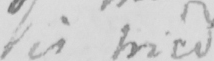What is written in this line of handwriting? is tried . 